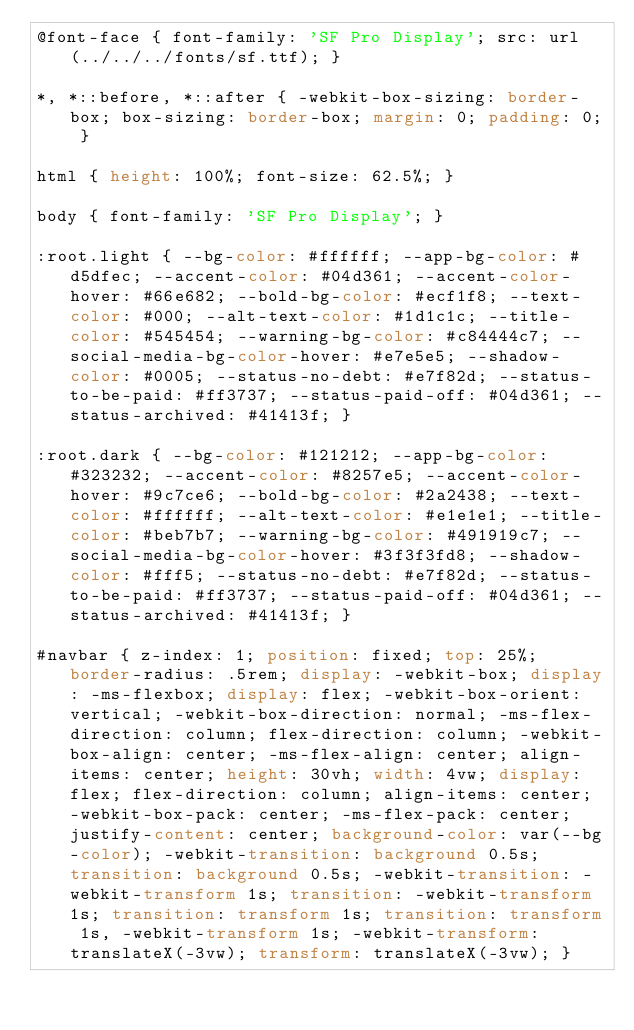Convert code to text. <code><loc_0><loc_0><loc_500><loc_500><_CSS_>@font-face { font-family: 'SF Pro Display'; src: url(../../../fonts/sf.ttf); }

*, *::before, *::after { -webkit-box-sizing: border-box; box-sizing: border-box; margin: 0; padding: 0; }

html { height: 100%; font-size: 62.5%; }

body { font-family: 'SF Pro Display'; }

:root.light { --bg-color: #ffffff; --app-bg-color: #d5dfec; --accent-color: #04d361; --accent-color-hover: #66e682; --bold-bg-color: #ecf1f8; --text-color: #000; --alt-text-color: #1d1c1c; --title-color: #545454; --warning-bg-color: #c84444c7; --social-media-bg-color-hover: #e7e5e5; --shadow-color: #0005; --status-no-debt: #e7f82d; --status-to-be-paid: #ff3737; --status-paid-off: #04d361; --status-archived: #41413f; }

:root.dark { --bg-color: #121212; --app-bg-color: #323232; --accent-color: #8257e5; --accent-color-hover: #9c7ce6; --bold-bg-color: #2a2438; --text-color: #ffffff; --alt-text-color: #e1e1e1; --title-color: #beb7b7; --warning-bg-color: #491919c7; --social-media-bg-color-hover: #3f3f3fd8; --shadow-color: #fff5; --status-no-debt: #e7f82d; --status-to-be-paid: #ff3737; --status-paid-off: #04d361; --status-archived: #41413f; }

#navbar { z-index: 1; position: fixed; top: 25%; border-radius: .5rem; display: -webkit-box; display: -ms-flexbox; display: flex; -webkit-box-orient: vertical; -webkit-box-direction: normal; -ms-flex-direction: column; flex-direction: column; -webkit-box-align: center; -ms-flex-align: center; align-items: center; height: 30vh; width: 4vw; display: flex; flex-direction: column; align-items: center; -webkit-box-pack: center; -ms-flex-pack: center; justify-content: center; background-color: var(--bg-color); -webkit-transition: background 0.5s; transition: background 0.5s; -webkit-transition: -webkit-transform 1s; transition: -webkit-transform 1s; transition: transform 1s; transition: transform 1s, -webkit-transform 1s; -webkit-transform: translateX(-3vw); transform: translateX(-3vw); }
</code> 